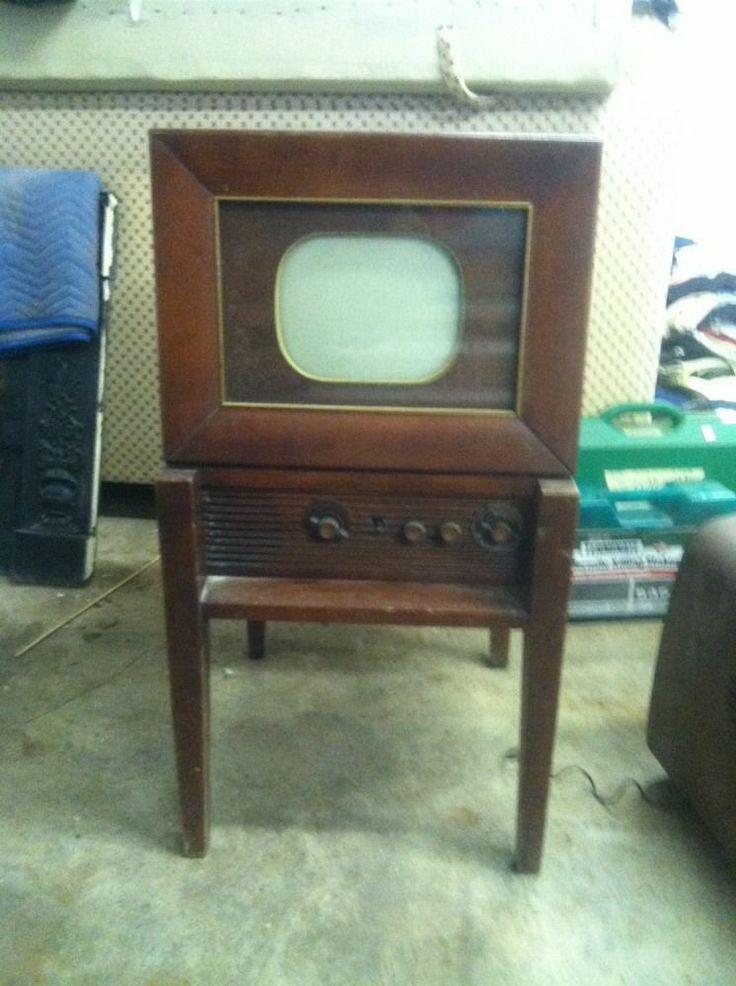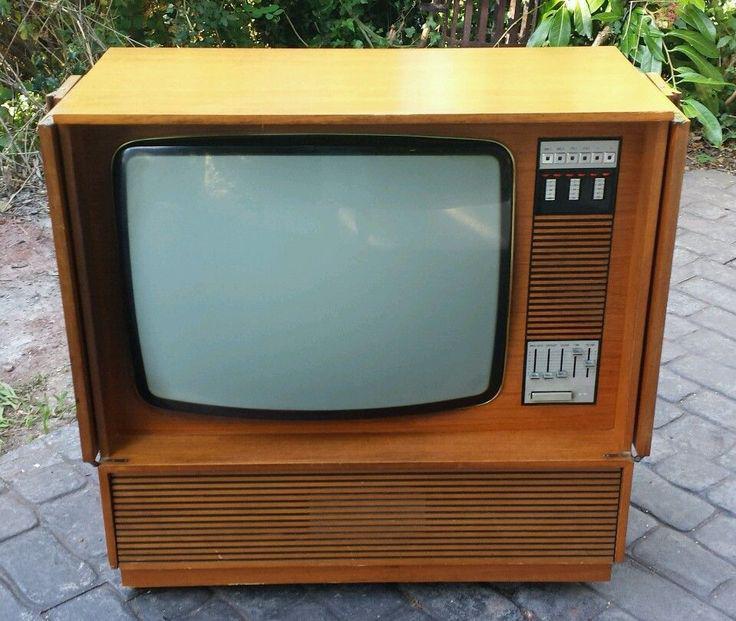The first image is the image on the left, the second image is the image on the right. Analyze the images presented: Is the assertion "Exactly one TV has four legs sitting on a hard, non-grassy surface, and at least one TV has a screen with four rounded corners." valid? Answer yes or no. Yes. The first image is the image on the left, the second image is the image on the right. Examine the images to the left and right. Is the description "In one image, a television and a radio unit are housed in a long wooden console cabinet on short legs that has speakers on the front and end." accurate? Answer yes or no. No. 